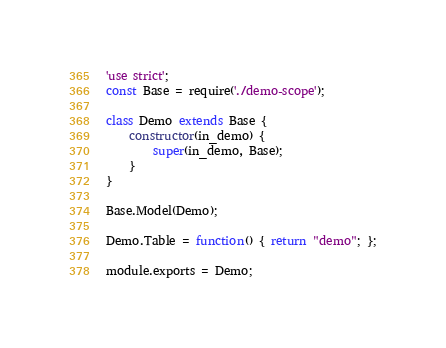<code> <loc_0><loc_0><loc_500><loc_500><_JavaScript_>'use strict';
const Base = require('./demo-scope');

class Demo extends Base {
    constructor(in_demo) {
        super(in_demo, Base);
    }
}

Base.Model(Demo);

Demo.Table = function() { return "demo"; };

module.exports = Demo;</code> 